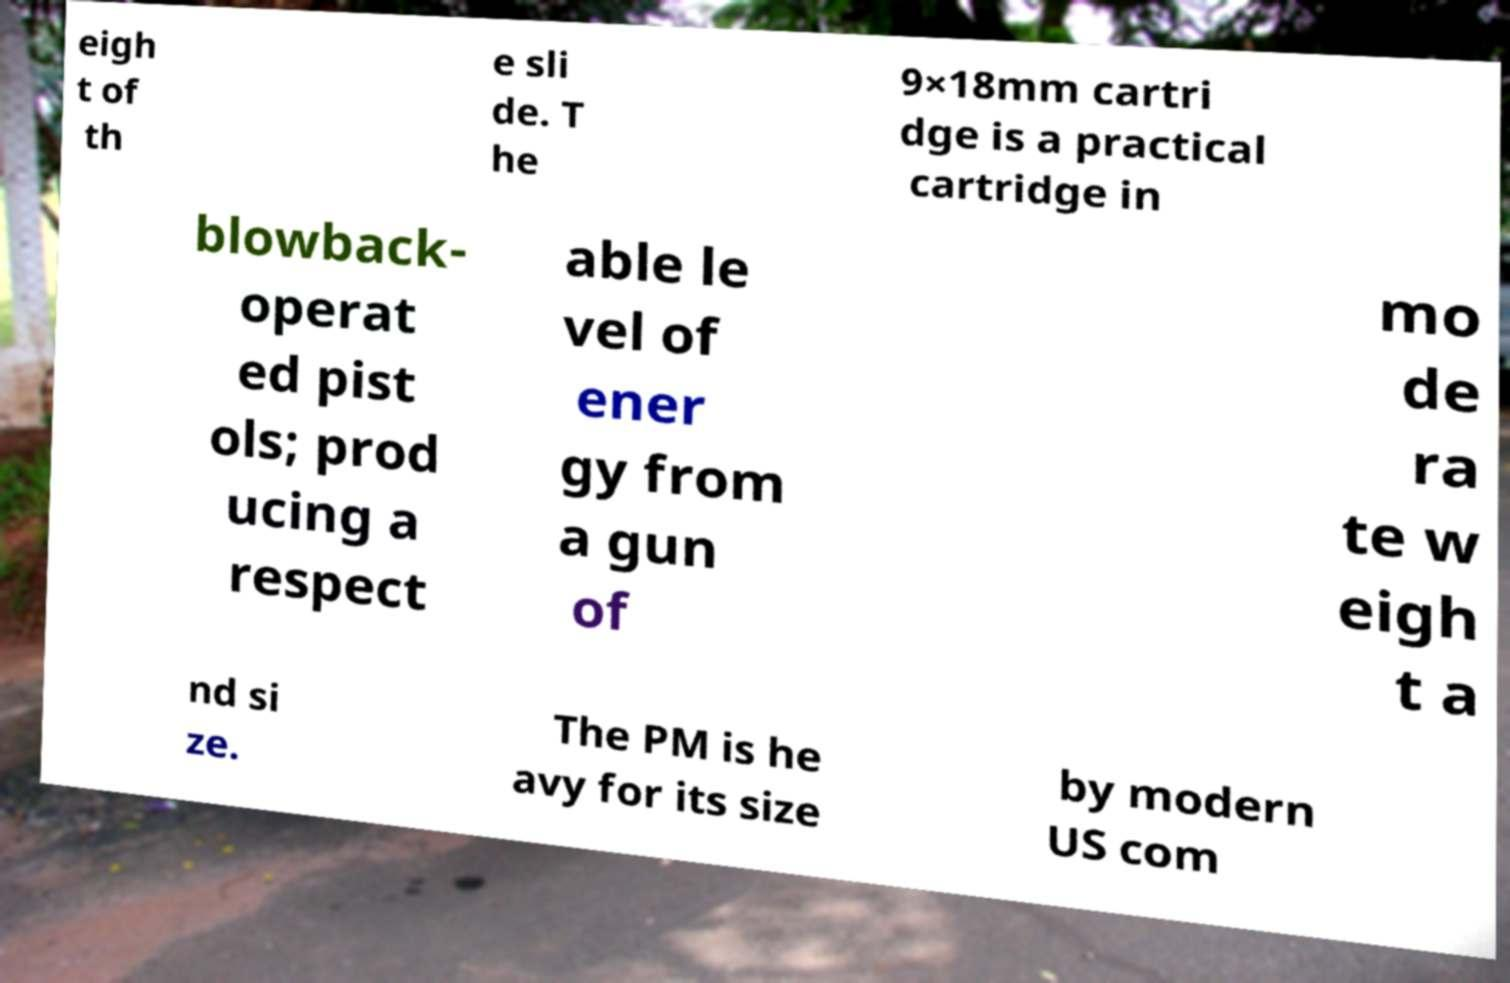What messages or text are displayed in this image? I need them in a readable, typed format. eigh t of th e sli de. T he 9×18mm cartri dge is a practical cartridge in blowback- operat ed pist ols; prod ucing a respect able le vel of ener gy from a gun of mo de ra te w eigh t a nd si ze. The PM is he avy for its size by modern US com 